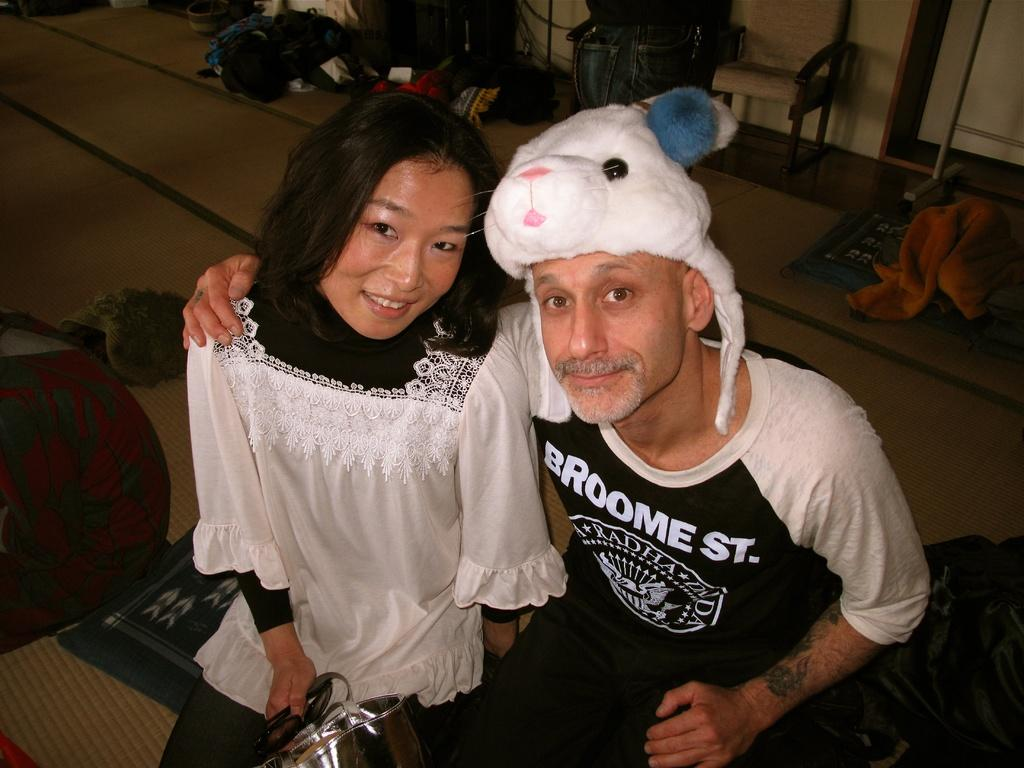How many people are sitting and smiling in the image? There are two people sitting and smiling in the image. Can you describe one of the people in the image? One of the people is a woman. What is the woman holding in the image? The woman is holding a bag. What is the surface they are sitting on in the image? There is a mat in the image. What type of items can be seen in the image? There are clothes visible in the image. What structure is present in the image? There is a stand in the image. What architectural feature is visible in the image? There is a door in the image. What type of background is present in the image? There is a wall in the image. How many objects can be seen in the image? There are various objects in the image. How many fish can be seen swimming in the image? There are no fish visible in the image. What type of light source is present in the image? There is no specific light source mentioned in the image; it only shows people, a mat, clothes, a stand, a door, a wall, and various objects. --- Facts: 1. There is a car in the image. 2. The car is red. 3. The car has four wheels. 4. There is a road in the image. 5. The road is paved. 6. There are trees in the background of the image. 7. The sky is visible in the image. Absurd Topics: bird, snow, mountain Conversation: What is the main subject of the image? The main subject of the image is a car. Can you describe the car in the image? The car is red and has four wheels. What type of surface can be seen in the image? There is a road in the image. How is the road constructed? The road is paved. What can be seen in the background of the image? There are trees in the background of the image. What is visible at the top of the image? The sky is visible in the image. Reasoning: Let's think step by step in order to produce the conversation. We start by identifying the main subject of the image, which is the car. Then, we describe specific details about the car, such as its color and the number of wheels. We also mention the road, its construction, and the presence of trees and the sky in the background. Each question is designed to elicit a specific detail about the image that is known from the provided facts. Absurd Question/Answer: Can you tell me how many birds are sitting on the car in the image? There are no birds visible on the car in the image. 